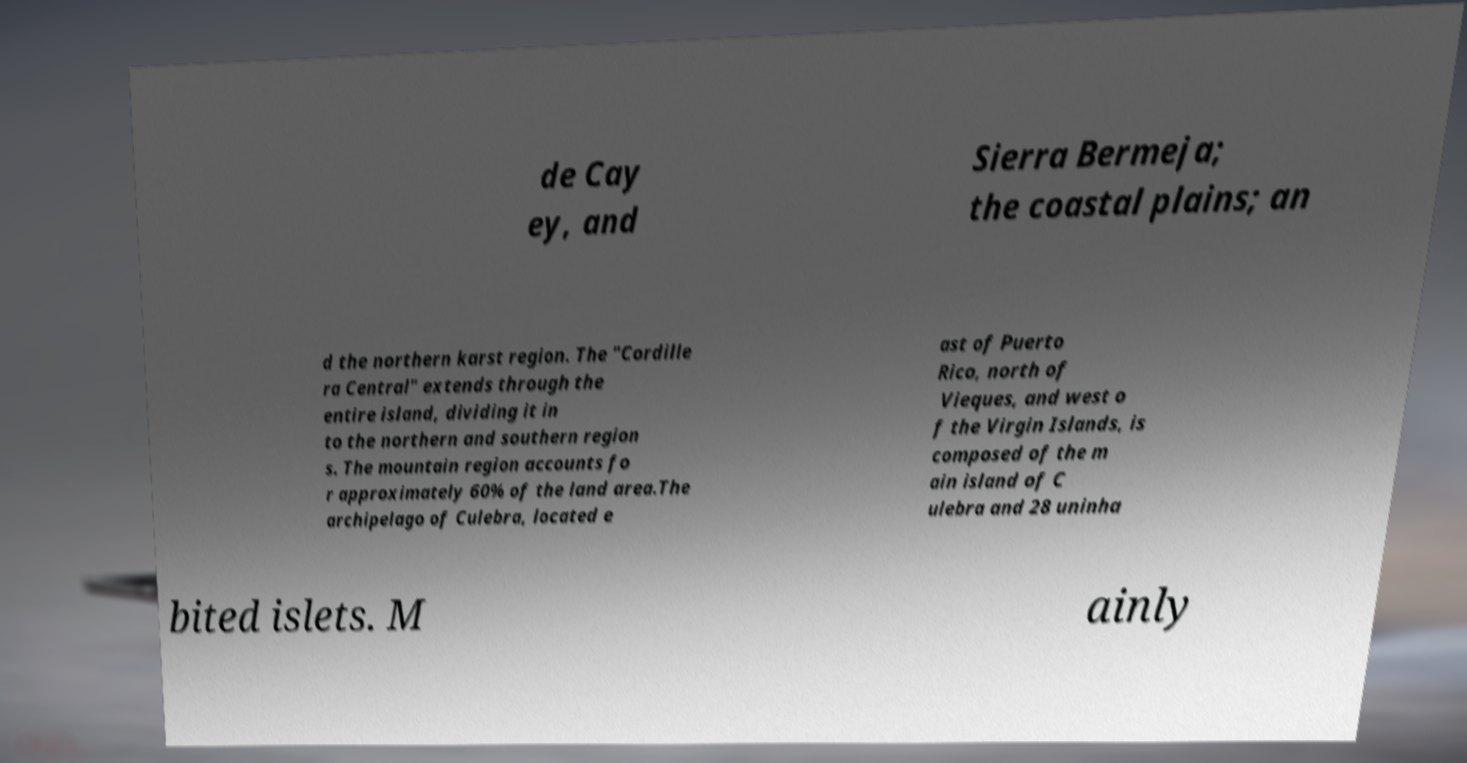Please identify and transcribe the text found in this image. de Cay ey, and Sierra Bermeja; the coastal plains; an d the northern karst region. The "Cordille ra Central" extends through the entire island, dividing it in to the northern and southern region s. The mountain region accounts fo r approximately 60% of the land area.The archipelago of Culebra, located e ast of Puerto Rico, north of Vieques, and west o f the Virgin Islands, is composed of the m ain island of C ulebra and 28 uninha bited islets. M ainly 